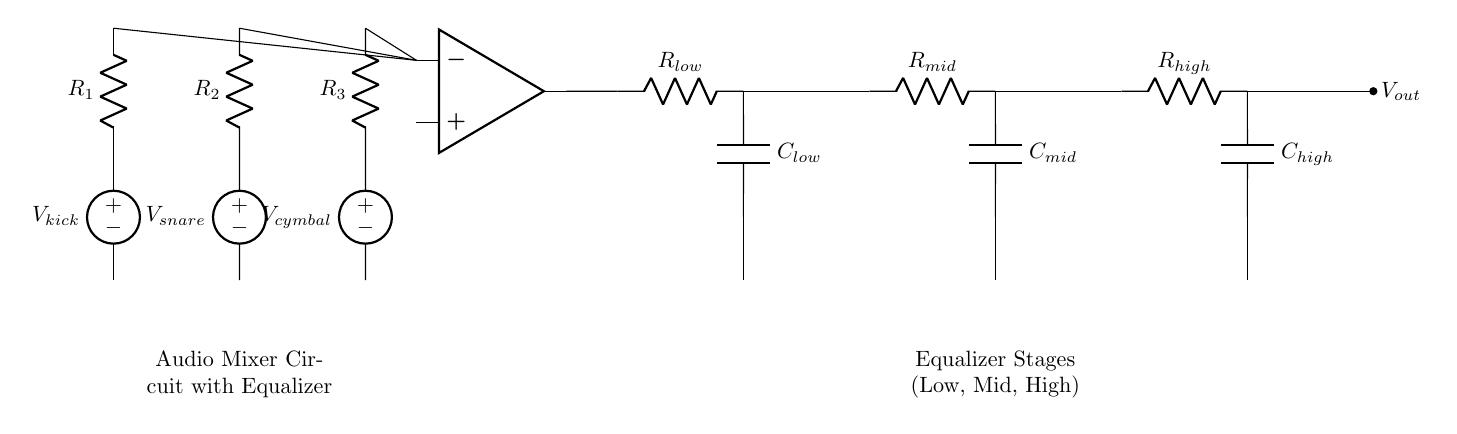What type of circuit is this? This circuit is an audio mixer circuit with an equalizer. The diagram shows multiple input sources leading to a mixer followed by equalization stages.
Answer: audio mixer circuit with equalizer What are the input sources labeled in the diagram? The input sources are labeled as V_kick for the kick drum, V_snare for the snare drum, and V_cymbal for the cymbal. This shows the voltage sources representing each percussion instrument.
Answer: V_kick, V_snare, V_cymbal How many equalizer stages are present in the circuit? There are three equalizer stages in the circuit: one for low frequencies, one for mid frequencies, and one for high frequencies. Each stage includes a resistor and a capacitor.
Answer: three What is the output voltage of the circuit labeled as? The output voltage of the circuit is labeled as V_out, indicating the resultant audio signal after mixing and equalization of the input sources.
Answer: V_out Why are operational amplifiers used in this circuit? Operational amplifiers are used to mix the signals from the different percussion instrument inputs. They serve to combine and amplify the signals to produce a balanced output.
Answer: to mix and amplify signals What components are part of the equalizer stages? The equalizer stages consist of resistors and capacitors, specifically labeled as R_low, C_low, R_mid, C_mid, R_high, and C_high. These components filter audio frequencies for balance.
Answer: resistors and capacitors What is the function of the resistors R_1, R_2, and R_3? The resistors R_1, R_2, and R_3 serve to limit the current from the input voltage sources of the percussion instruments before they reach the operational amplifier.
Answer: to limit current 